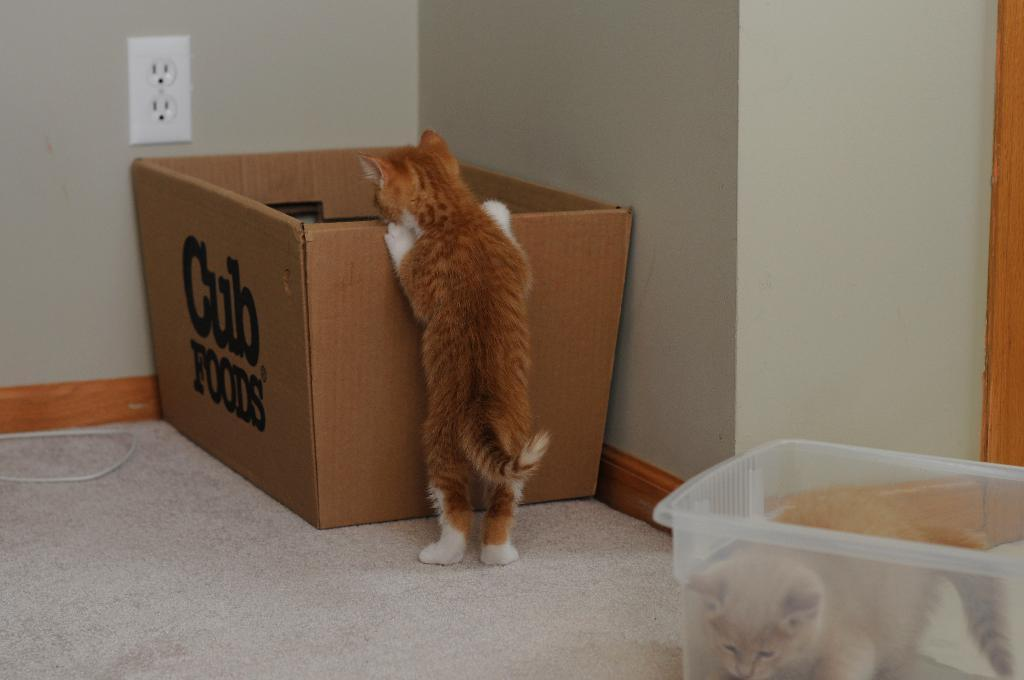<image>
Write a terse but informative summary of the picture. Cub Foods is printed onto the side of the box this curious cat is investigating. 